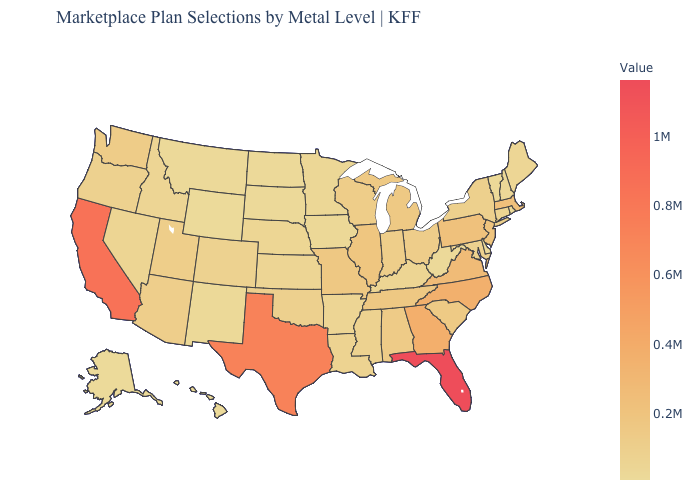Among the states that border Montana , which have the lowest value?
Short answer required. Wyoming. Is the legend a continuous bar?
Give a very brief answer. Yes. Does Louisiana have the highest value in the USA?
Write a very short answer. No. Does New Hampshire have the highest value in the Northeast?
Give a very brief answer. No. Does Alaska have the lowest value in the USA?
Keep it brief. Yes. Among the states that border New York , does Vermont have the lowest value?
Concise answer only. Yes. 